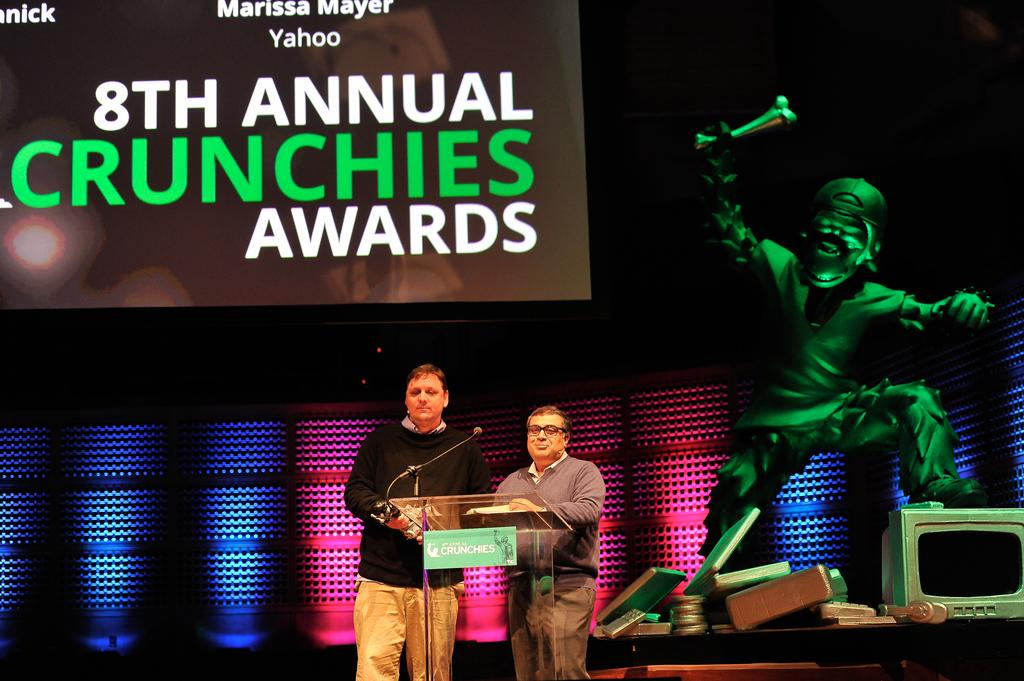<image>
Present a compact description of the photo's key features. the 8th annual crunchies awards has a man in green holding a bone 